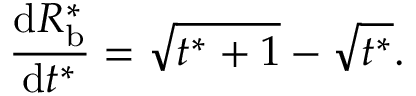Convert formula to latex. <formula><loc_0><loc_0><loc_500><loc_500>\frac { d R _ { b } ^ { * } } { d t ^ { * } } = \sqrt { t ^ { * } + 1 } - \sqrt { t ^ { * } } .</formula> 